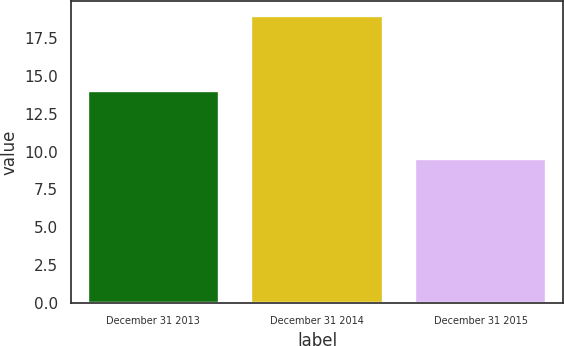Convert chart. <chart><loc_0><loc_0><loc_500><loc_500><bar_chart><fcel>December 31 2013<fcel>December 31 2014<fcel>December 31 2015<nl><fcel>14<fcel>19<fcel>9.5<nl></chart> 